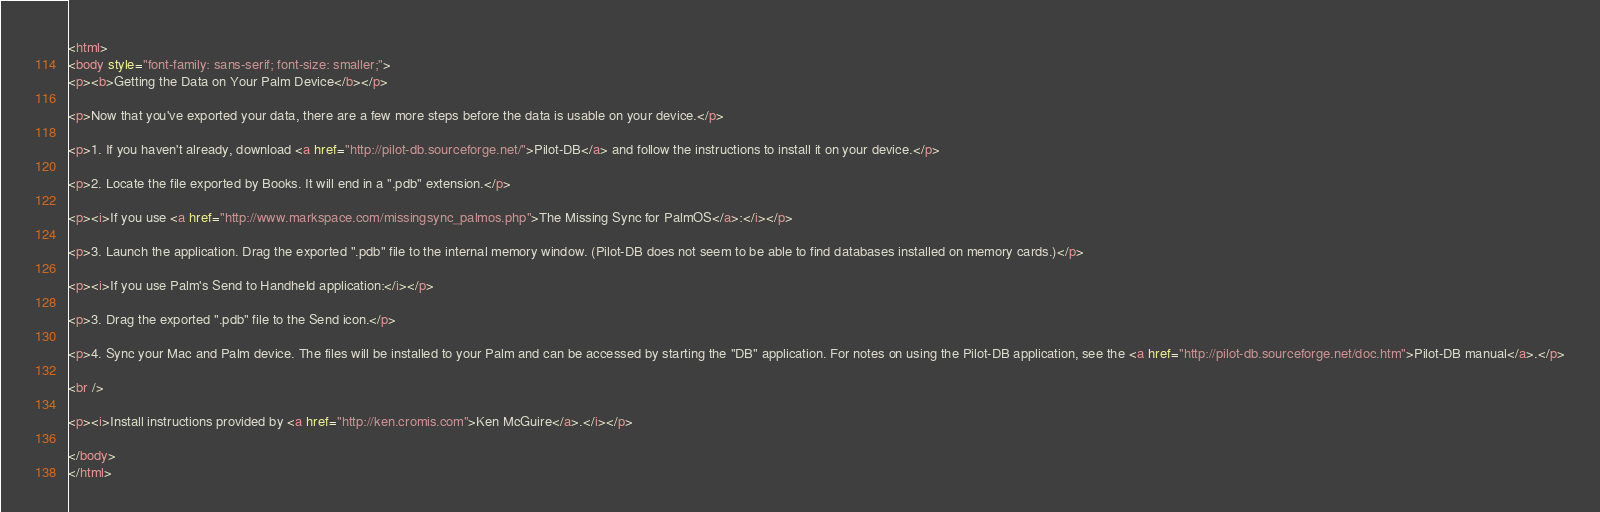<code> <loc_0><loc_0><loc_500><loc_500><_HTML_><html>
<body style="font-family: sans-serif; font-size: smaller;">
<p><b>Getting the Data on Your Palm Device</b></p>

<p>Now that you've exported your data, there are a few more steps before the data is usable on your device.</p>

<p>1. If you haven't already, download <a href="http://pilot-db.sourceforge.net/">Pilot-DB</a> and follow the instructions to install it on your device.</p>

<p>2. Locate the file exported by Books. It will end in a ".pdb" extension.</p>

<p><i>If you use <a href="http://www.markspace.com/missingsync_palmos.php">The Missing Sync for PalmOS</a>:</i></p>

<p>3. Launch the application. Drag the exported ".pdb" file to the internal memory window. (Pilot-DB does not seem to be able to find databases installed on memory cards.)</p>

<p><i>If you use Palm's Send to Handheld application:</i></p>

<p>3. Drag the exported ".pdb" file to the Send icon.</p>

<p>4. Sync your Mac and Palm device. The files will be installed to your Palm and can be accessed by starting the "DB" application. For notes on using the Pilot-DB application, see the <a href="http://pilot-db.sourceforge.net/doc.htm">Pilot-DB manual</a>.</p>

<br />

<p><i>Install instructions provided by <a href="http://ken.cromis.com">Ken McGuire</a>.</i></p>

</body>
</html></code> 